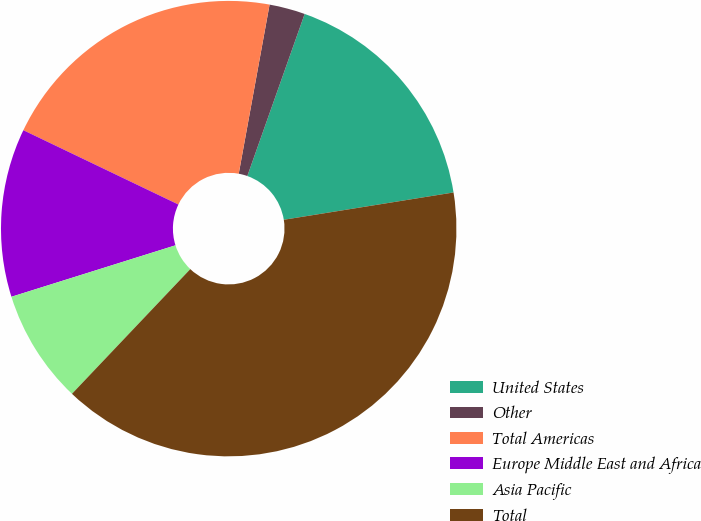Convert chart. <chart><loc_0><loc_0><loc_500><loc_500><pie_chart><fcel>United States<fcel>Other<fcel>Total Americas<fcel>Europe Middle East and Africa<fcel>Asia Pacific<fcel>Total<nl><fcel>17.05%<fcel>2.54%<fcel>20.76%<fcel>11.95%<fcel>8.08%<fcel>39.62%<nl></chart> 